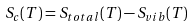<formula> <loc_0><loc_0><loc_500><loc_500>S _ { c } ( T ) = S _ { t o t a l } ( T ) - S _ { v i b } ( T )</formula> 